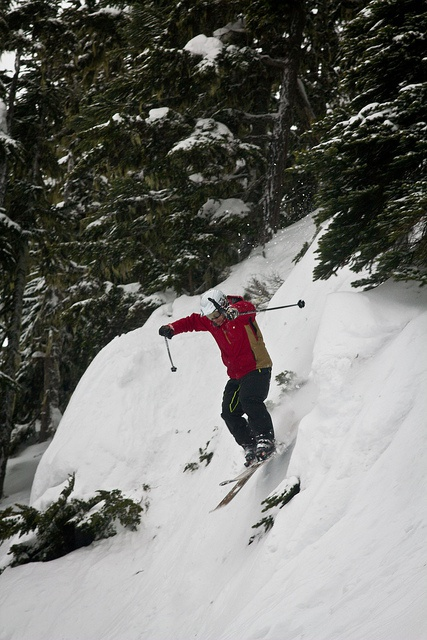Describe the objects in this image and their specific colors. I can see people in black, maroon, and gray tones and skis in black, gray, darkgray, and lightgray tones in this image. 